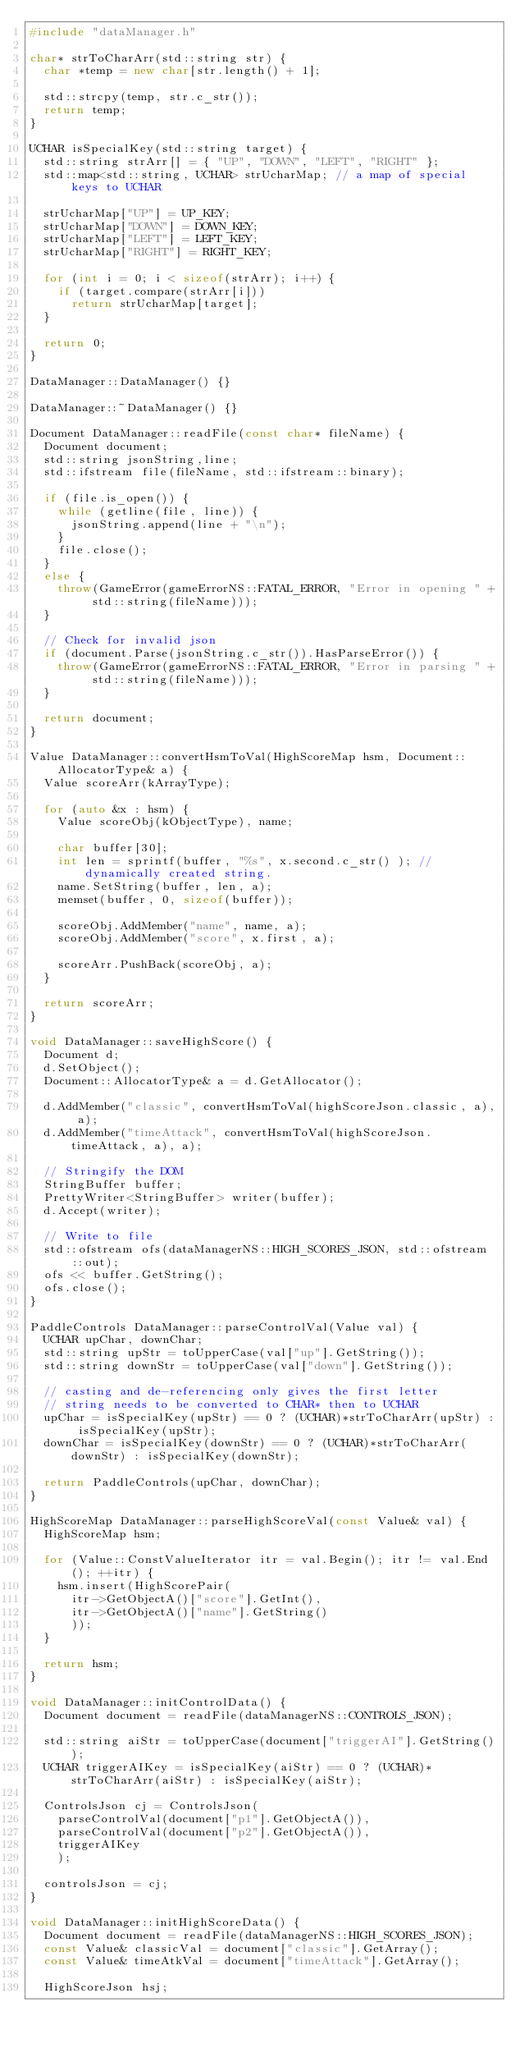Convert code to text. <code><loc_0><loc_0><loc_500><loc_500><_C++_>#include "dataManager.h"

char* strToCharArr(std::string str) {
	char *temp = new char[str.length() + 1];

	std::strcpy(temp, str.c_str());
	return temp;
}

UCHAR isSpecialKey(std::string target) {
	std::string strArr[] = { "UP", "DOWN", "LEFT", "RIGHT" };
	std::map<std::string, UCHAR> strUcharMap;	// a map of special keys to UCHAR

	strUcharMap["UP"] = UP_KEY;
	strUcharMap["DOWN"] = DOWN_KEY;
	strUcharMap["LEFT"] = LEFT_KEY;
	strUcharMap["RIGHT"] = RIGHT_KEY;

	for (int i = 0; i < sizeof(strArr); i++) {
		if (target.compare(strArr[i]))
			return strUcharMap[target];
	}

	return 0;
}

DataManager::DataManager() {}

DataManager::~DataManager() {}

Document DataManager::readFile(const char* fileName) {
	Document document;
	std::string jsonString,line;
	std::ifstream file(fileName, std::ifstream::binary);

	if (file.is_open()) {
		while (getline(file, line)) {
			jsonString.append(line + "\n");
		}
		file.close();
	}
	else {
		throw(GameError(gameErrorNS::FATAL_ERROR, "Error in opening " + std::string(fileName)));
	}

	// Check for invalid json
	if (document.Parse(jsonString.c_str()).HasParseError()) {
		throw(GameError(gameErrorNS::FATAL_ERROR, "Error in parsing " + std::string(fileName)));
	}

	return document;
}

Value DataManager::convertHsmToVal(HighScoreMap hsm, Document::AllocatorType& a) {
	Value scoreArr(kArrayType);

	for (auto &x : hsm) {
		Value scoreObj(kObjectType), name;

		char buffer[30];
		int len = sprintf(buffer, "%s", x.second.c_str() ); // dynamically created string.
		name.SetString(buffer, len, a);
		memset(buffer, 0, sizeof(buffer));

		scoreObj.AddMember("name", name, a);
		scoreObj.AddMember("score", x.first, a);
		
		scoreArr.PushBack(scoreObj, a);
	}

	return scoreArr;
}

void DataManager::saveHighScore() {
	Document d;
	d.SetObject();
	Document::AllocatorType& a = d.GetAllocator();

	d.AddMember("classic", convertHsmToVal(highScoreJson.classic, a), a);
	d.AddMember("timeAttack", convertHsmToVal(highScoreJson.timeAttack, a), a);

	// Stringify the DOM
	StringBuffer buffer;
	PrettyWriter<StringBuffer> writer(buffer);
	d.Accept(writer);

	// Write to file 
	std::ofstream ofs(dataManagerNS::HIGH_SCORES_JSON, std::ofstream::out);
	ofs << buffer.GetString();
	ofs.close();
}

PaddleControls DataManager::parseControlVal(Value val) {
	UCHAR upChar, downChar;
	std::string upStr = toUpperCase(val["up"].GetString());
	std::string downStr = toUpperCase(val["down"].GetString());

	// casting and de-referencing only gives the first letter
	// string needs to be converted to CHAR* then to UCHAR
	upChar = isSpecialKey(upStr) == 0 ? (UCHAR)*strToCharArr(upStr) : isSpecialKey(upStr);
	downChar = isSpecialKey(downStr) == 0 ? (UCHAR)*strToCharArr(downStr) : isSpecialKey(downStr);

	return PaddleControls(upChar, downChar);
}

HighScoreMap DataManager::parseHighScoreVal(const Value& val) {
	HighScoreMap hsm;

	for (Value::ConstValueIterator itr = val.Begin(); itr != val.End(); ++itr) {
		hsm.insert(HighScorePair(
			itr->GetObjectA()["score"].GetInt(),
			itr->GetObjectA()["name"].GetString()
			));	
	}
	
	return hsm;
}

void DataManager::initControlData() {
	Document document = readFile(dataManagerNS::CONTROLS_JSON);

	std::string aiStr = toUpperCase(document["triggerAI"].GetString());
	UCHAR triggerAIKey = isSpecialKey(aiStr) == 0 ? (UCHAR)*strToCharArr(aiStr) : isSpecialKey(aiStr);
	
	ControlsJson cj = ControlsJson(
		parseControlVal(document["p1"].GetObjectA()),
		parseControlVal(document["p2"].GetObjectA()),
		triggerAIKey
		);

	controlsJson = cj;
}

void DataManager::initHighScoreData() {
	Document document = readFile(dataManagerNS::HIGH_SCORES_JSON);
	const Value& classicVal = document["classic"].GetArray();
	const Value& timeAtkVal = document["timeAttack"].GetArray();
	
	HighScoreJson hsj;</code> 